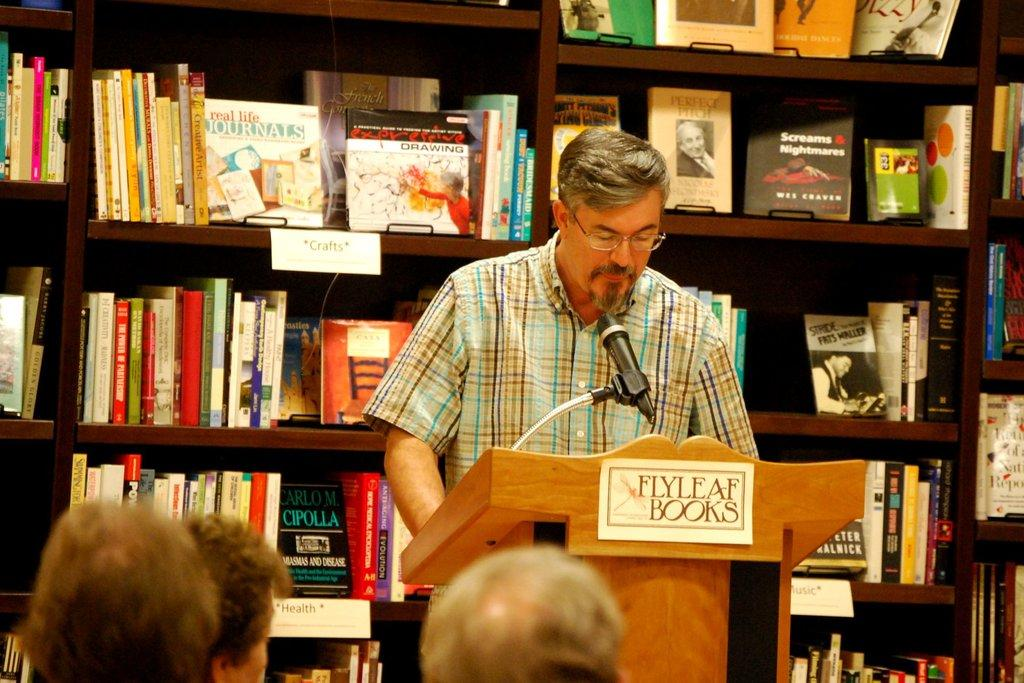<image>
Write a terse but informative summary of the picture. A man speaks to a small group of people and he is standing in front of a large bookcase with many books on it. 